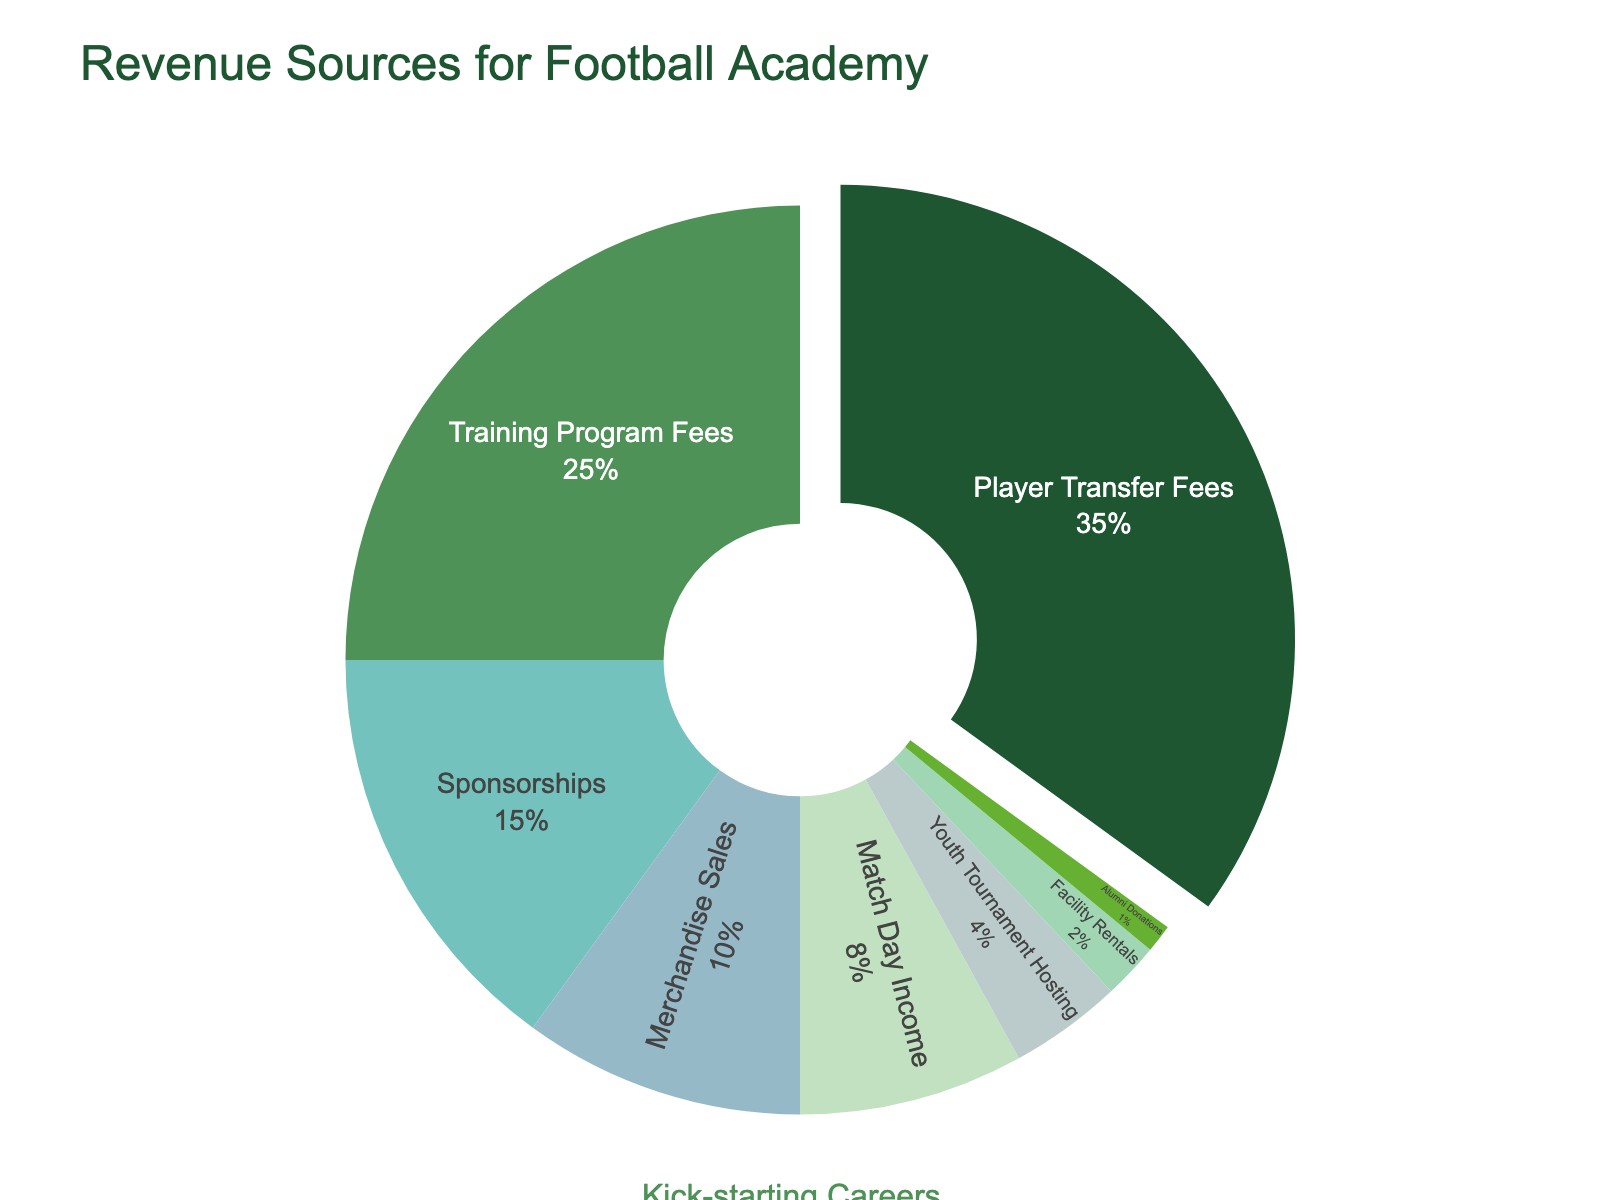What percentage of the revenue comes from the top two sources combined? The top two revenue sources are Player Transfer Fees and Training Program Fees. Adding their percentages: 35% + 25% = 60%.
Answer: 60% Which revenue source contributes the least to the total revenue? The revenue source with the smallest percentage is Alumni Donations at 1%.
Answer: Alumni Donations How much more does Player Transfer Fees contribute to the revenue compared to Match Day Income? Player Transfer Fees contribute 35%, while Match Day Income contributes 8%. The difference is 35% - 8% = 27%.
Answer: 27% What is the combined revenue from Merchandise Sales and Youth Tournament Hosting? Adding the percentages for Merchandise Sales and Youth Tournament Hosting: 10% + 4% = 14%.
Answer: 14% Which revenue source has a larger contribution, Sponsorships or Facility Rentals? Sponsorships contribute 15%, while Facility Rentals contribute 2%. Comparison reveals 15% is greater than 2%.
Answer: Sponsorships List all the revenue sources that contribute less than 10% each The revenue sources contributing less than 10% are Match Day Income (8%), Youth Tournament Hosting (4%), Facility Rentals (2%), and Alumni Donations (1%).
Answer: Match Day Income, Youth Tournament Hosting, Facility Rentals, Alumni Donations By how much does the Training Program Fees percentage exceed that of Merchandise Sales? Training Program Fees contribute 25%, and Merchandise Sales contribute 10%. Difference is 25% - 10% = 15%.
Answer: 15% What fraction of the total revenue is generated by sources contributing under 5% each? Adding the percentages of sources under 5%: Youth Tournament Hosting (4%), Facility Rentals (2%), Alumni Donations (1%) equals 4% + 2% + 1% = 7%.
Answer: 7% Identify the revenue source represented by the largest segment in the pie chart The largest segment in the pie chart represents Player Transfer Fees at 35%.
Answer: Player Transfer Fees Which revenue source contributes exactly one-fourth of Player Transfer Fees? Player Transfer Fees are 35%. One-fourth of this is 35% / 4 = 8.75%. No revenue source exactly matches 8.75%, but Training Program Fees come close at 25%.
Answer: None 